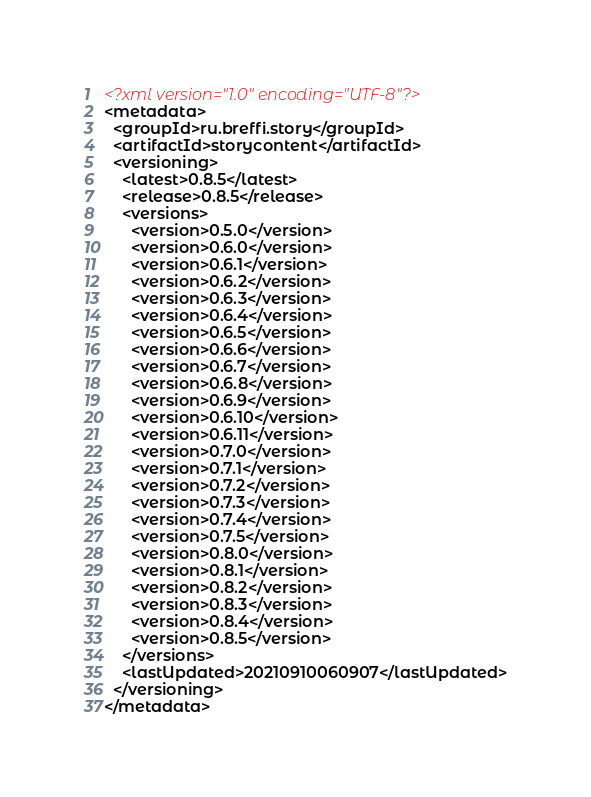Convert code to text. <code><loc_0><loc_0><loc_500><loc_500><_XML_><?xml version="1.0" encoding="UTF-8"?>
<metadata>
  <groupId>ru.breffi.story</groupId>
  <artifactId>storycontent</artifactId>
  <versioning>
    <latest>0.8.5</latest>
    <release>0.8.5</release>
    <versions>
      <version>0.5.0</version>
      <version>0.6.0</version>
      <version>0.6.1</version>
      <version>0.6.2</version>
      <version>0.6.3</version>
      <version>0.6.4</version>
      <version>0.6.5</version>
      <version>0.6.6</version>
      <version>0.6.7</version>
      <version>0.6.8</version>
      <version>0.6.9</version>
      <version>0.6.10</version>
      <version>0.6.11</version>
      <version>0.7.0</version>
      <version>0.7.1</version>
      <version>0.7.2</version>
      <version>0.7.3</version>
      <version>0.7.4</version>
      <version>0.7.5</version>
      <version>0.8.0</version>
      <version>0.8.1</version>
      <version>0.8.2</version>
      <version>0.8.3</version>
      <version>0.8.4</version>
      <version>0.8.5</version>
    </versions>
    <lastUpdated>20210910060907</lastUpdated>
  </versioning>
</metadata>
</code> 